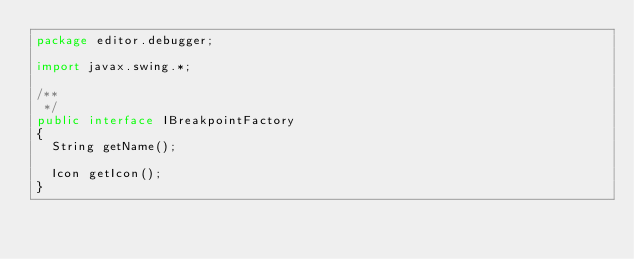Convert code to text. <code><loc_0><loc_0><loc_500><loc_500><_Java_>package editor.debugger;

import javax.swing.*;

/**
 */
public interface IBreakpointFactory
{
  String getName();

  Icon getIcon();
}
</code> 